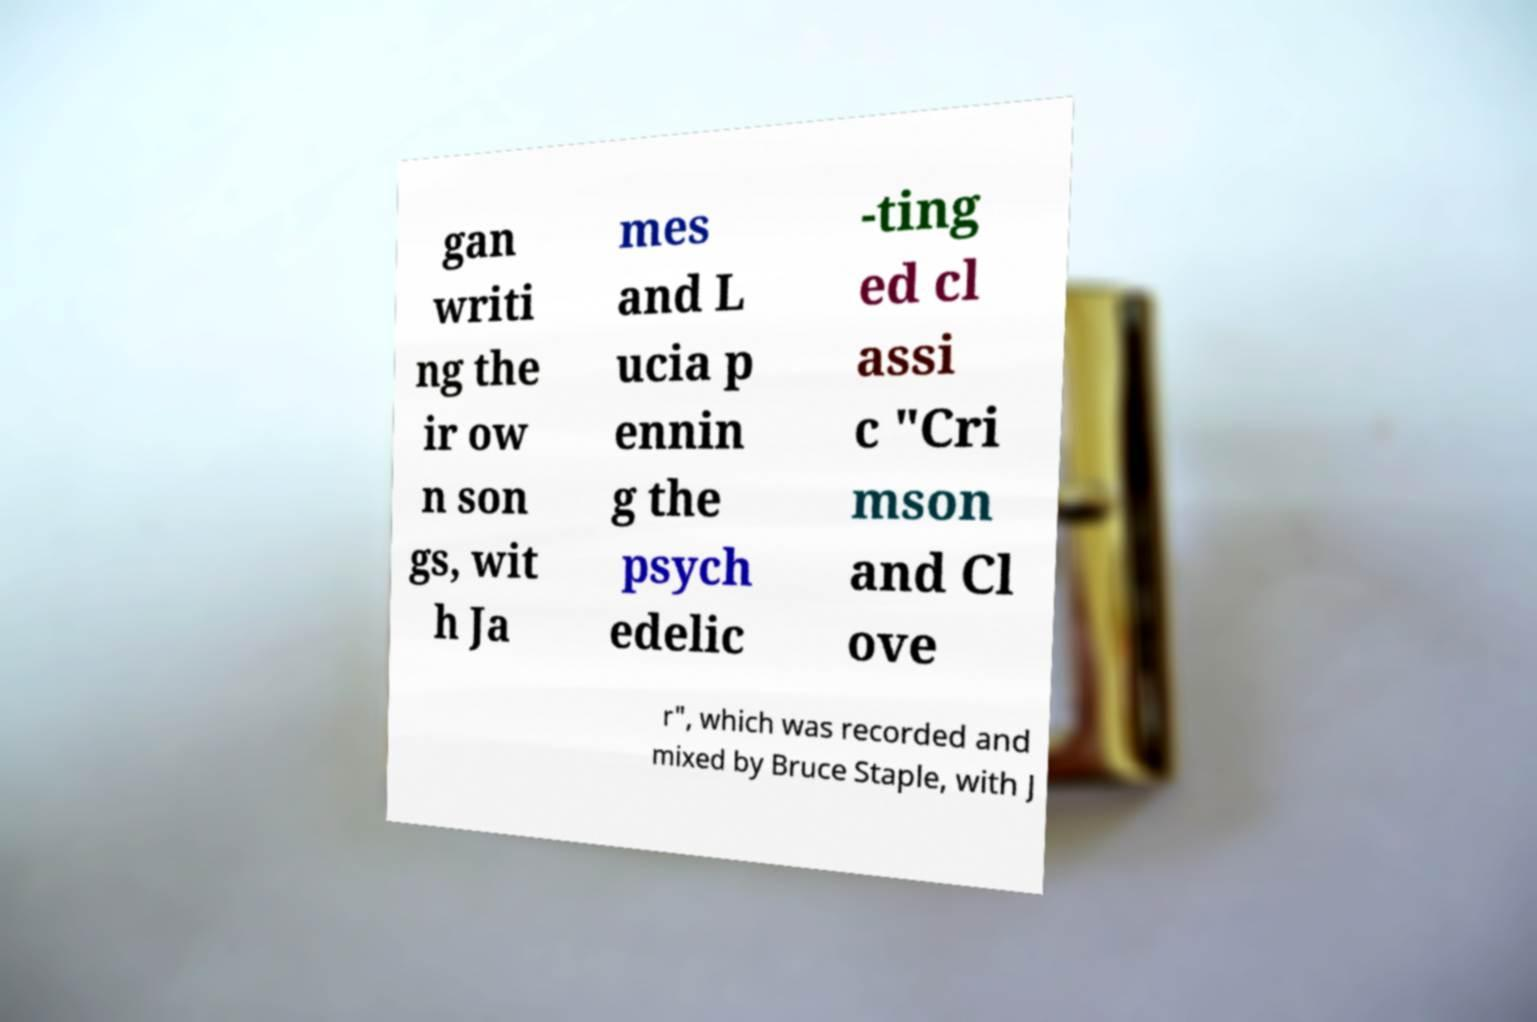Can you read and provide the text displayed in the image?This photo seems to have some interesting text. Can you extract and type it out for me? gan writi ng the ir ow n son gs, wit h Ja mes and L ucia p ennin g the psych edelic -ting ed cl assi c "Cri mson and Cl ove r", which was recorded and mixed by Bruce Staple, with J 